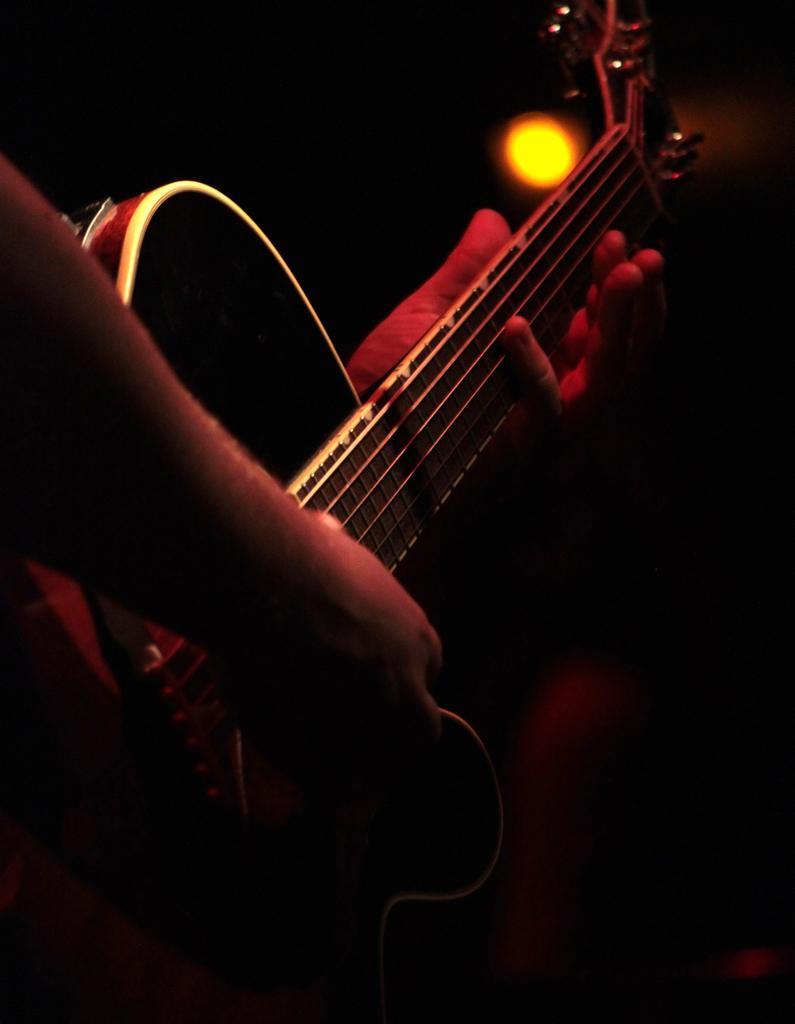How would you summarize this image in a sentence or two? In the image we can see there is a person who is holding on guitar in his hand. 